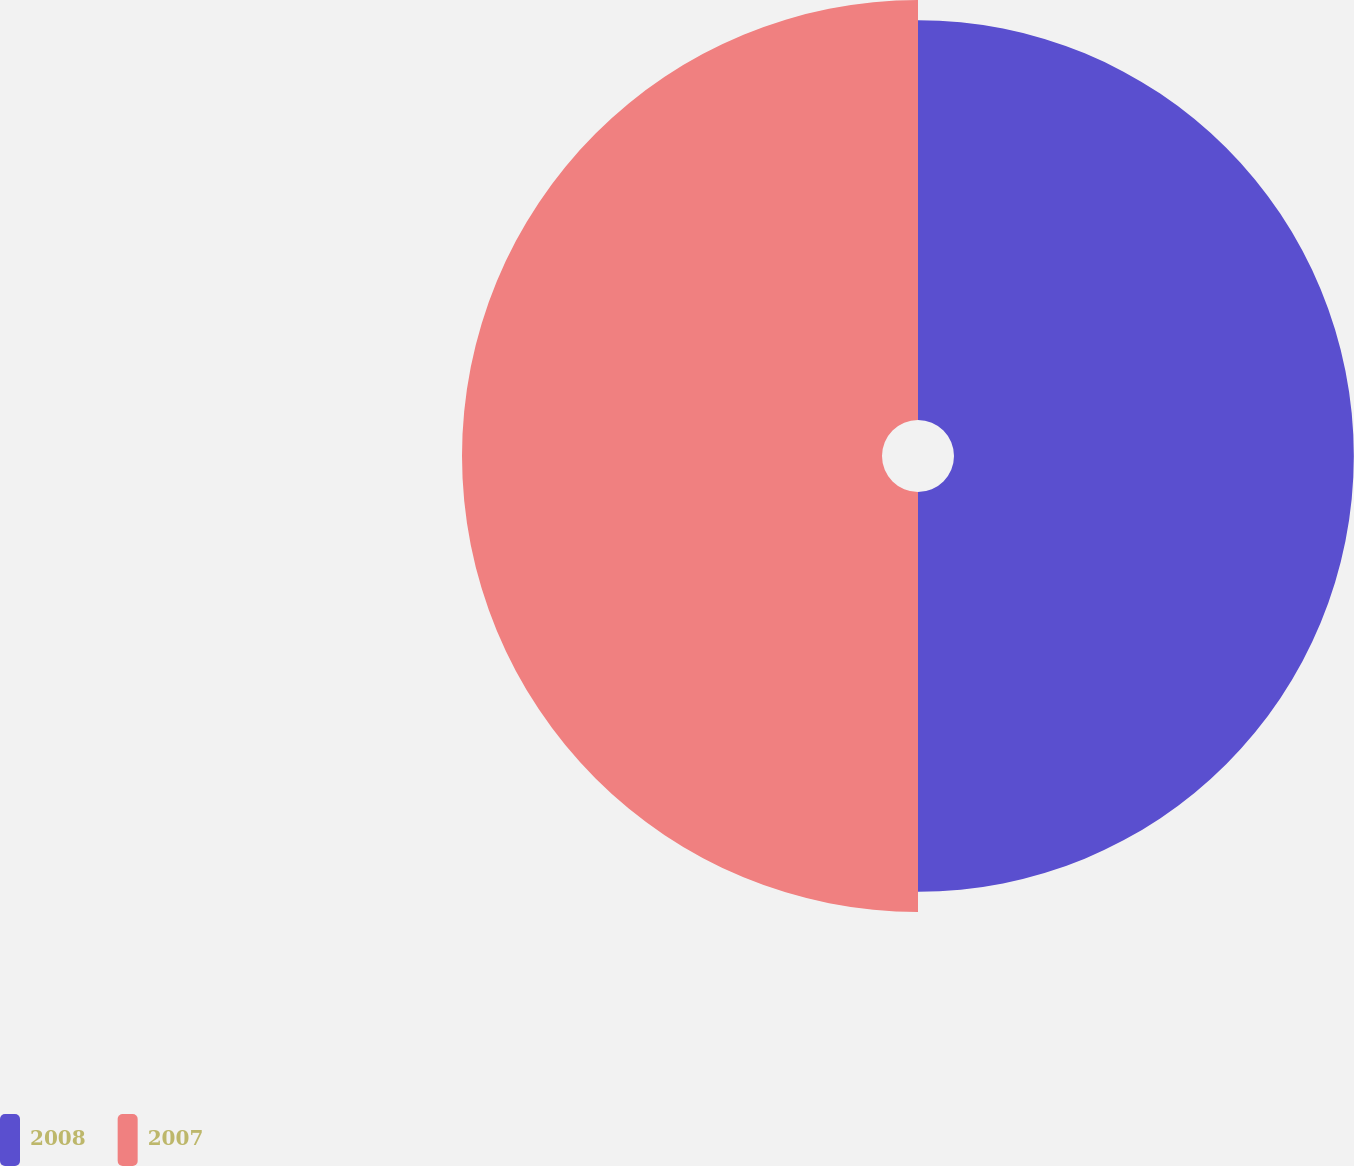Convert chart to OTSL. <chart><loc_0><loc_0><loc_500><loc_500><pie_chart><fcel>2008<fcel>2007<nl><fcel>48.77%<fcel>51.23%<nl></chart> 